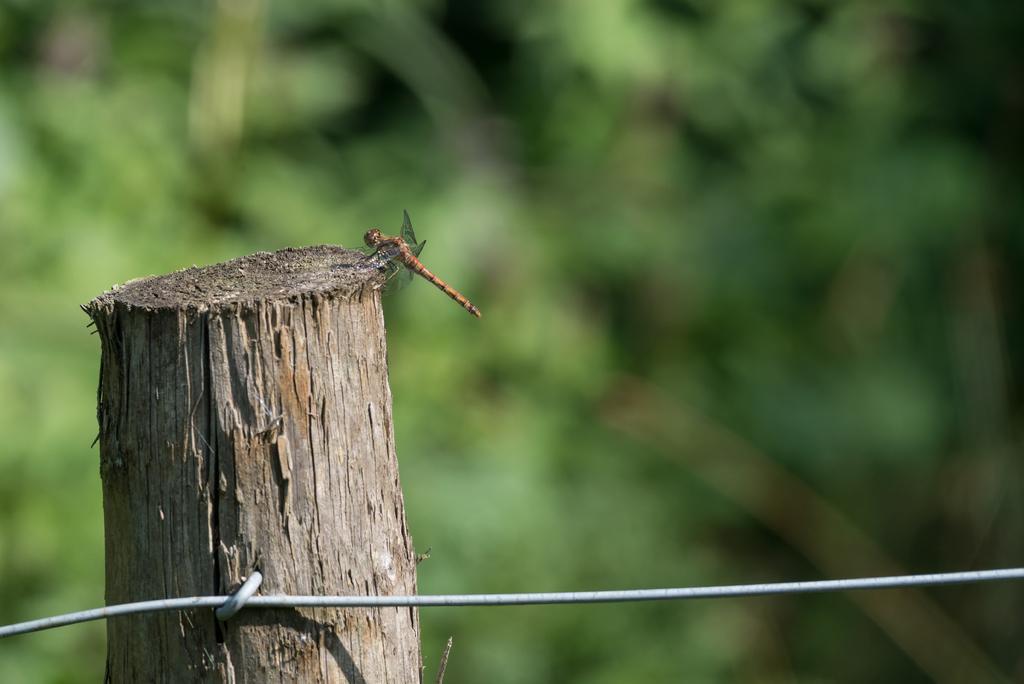How would you summarize this image in a sentence or two? In this image we can see a fly, here is the bark, at background it is in green color. 